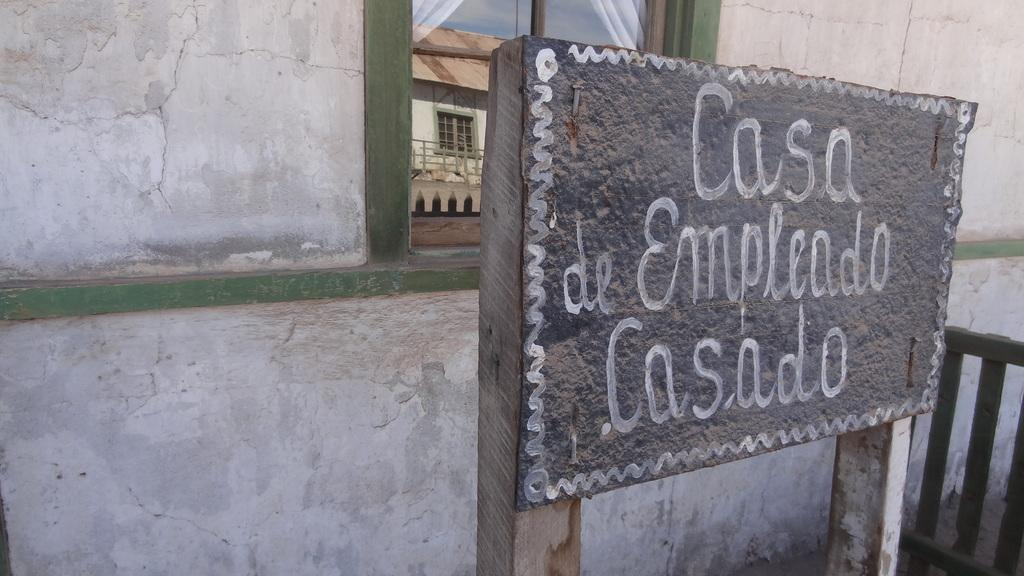What is written on in the image? There is text written on a board in the image. What can be seen behind the board? There is a glass window behind the board. What type of material is used for the fence beside the board? There is a wooden fence beside the board. What type of badge is being measured in the image? There is no badge present in the image, and therefore no measurement is taking place. 